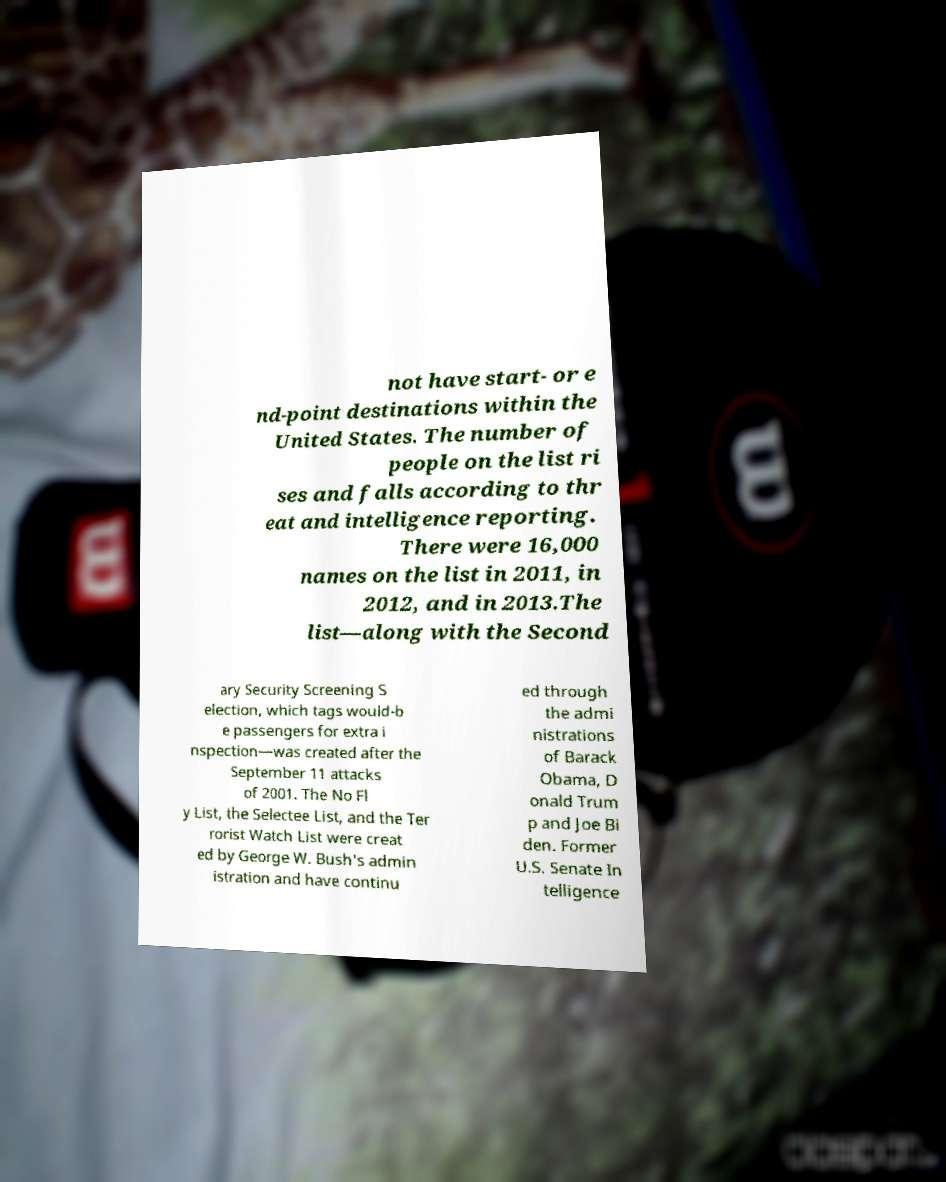Could you assist in decoding the text presented in this image and type it out clearly? not have start- or e nd-point destinations within the United States. The number of people on the list ri ses and falls according to thr eat and intelligence reporting. There were 16,000 names on the list in 2011, in 2012, and in 2013.The list—along with the Second ary Security Screening S election, which tags would-b e passengers for extra i nspection—was created after the September 11 attacks of 2001. The No Fl y List, the Selectee List, and the Ter rorist Watch List were creat ed by George W. Bush's admin istration and have continu ed through the admi nistrations of Barack Obama, D onald Trum p and Joe Bi den. Former U.S. Senate In telligence 